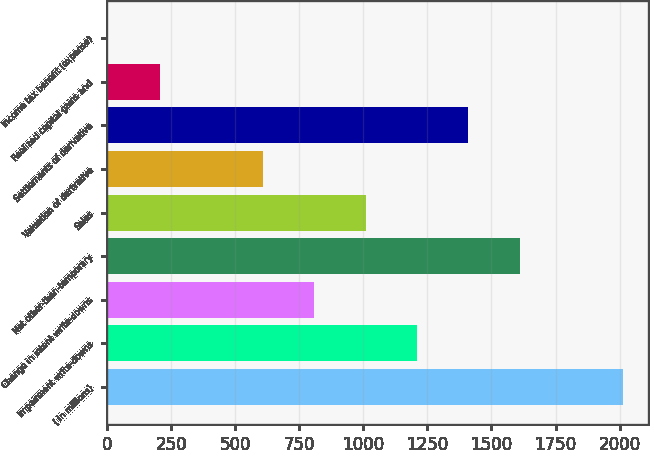<chart> <loc_0><loc_0><loc_500><loc_500><bar_chart><fcel>( in millions)<fcel>Impairment write-downs<fcel>Change in intent write-downs<fcel>Net other-than-temporary<fcel>Sales<fcel>Valuation of derivative<fcel>Settlements of derivative<fcel>Realized capital gains and<fcel>Income tax benefit (expense)<nl><fcel>2012<fcel>1209.2<fcel>807.8<fcel>1610.6<fcel>1008.5<fcel>607.1<fcel>1409.9<fcel>205.7<fcel>5<nl></chart> 